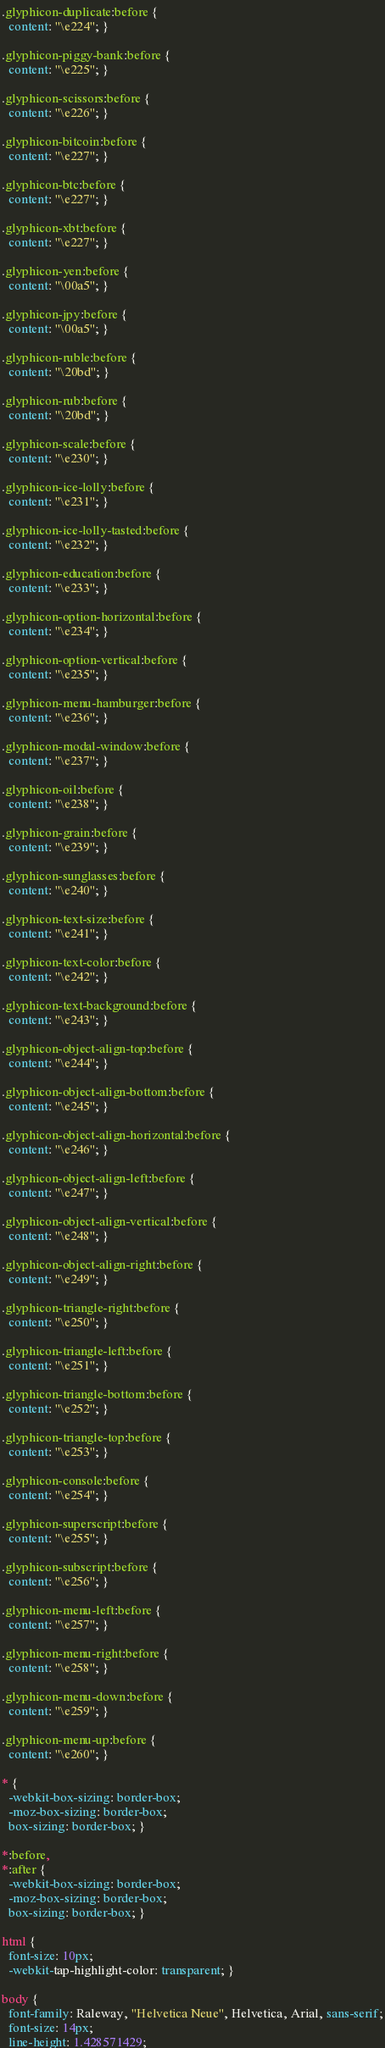Convert code to text. <code><loc_0><loc_0><loc_500><loc_500><_CSS_>
.glyphicon-duplicate:before {
  content: "\e224"; }

.glyphicon-piggy-bank:before {
  content: "\e225"; }

.glyphicon-scissors:before {
  content: "\e226"; }

.glyphicon-bitcoin:before {
  content: "\e227"; }

.glyphicon-btc:before {
  content: "\e227"; }

.glyphicon-xbt:before {
  content: "\e227"; }

.glyphicon-yen:before {
  content: "\00a5"; }

.glyphicon-jpy:before {
  content: "\00a5"; }

.glyphicon-ruble:before {
  content: "\20bd"; }

.glyphicon-rub:before {
  content: "\20bd"; }

.glyphicon-scale:before {
  content: "\e230"; }

.glyphicon-ice-lolly:before {
  content: "\e231"; }

.glyphicon-ice-lolly-tasted:before {
  content: "\e232"; }

.glyphicon-education:before {
  content: "\e233"; }

.glyphicon-option-horizontal:before {
  content: "\e234"; }

.glyphicon-option-vertical:before {
  content: "\e235"; }

.glyphicon-menu-hamburger:before {
  content: "\e236"; }

.glyphicon-modal-window:before {
  content: "\e237"; }

.glyphicon-oil:before {
  content: "\e238"; }

.glyphicon-grain:before {
  content: "\e239"; }

.glyphicon-sunglasses:before {
  content: "\e240"; }

.glyphicon-text-size:before {
  content: "\e241"; }

.glyphicon-text-color:before {
  content: "\e242"; }

.glyphicon-text-background:before {
  content: "\e243"; }

.glyphicon-object-align-top:before {
  content: "\e244"; }

.glyphicon-object-align-bottom:before {
  content: "\e245"; }

.glyphicon-object-align-horizontal:before {
  content: "\e246"; }

.glyphicon-object-align-left:before {
  content: "\e247"; }

.glyphicon-object-align-vertical:before {
  content: "\e248"; }

.glyphicon-object-align-right:before {
  content: "\e249"; }

.glyphicon-triangle-right:before {
  content: "\e250"; }

.glyphicon-triangle-left:before {
  content: "\e251"; }

.glyphicon-triangle-bottom:before {
  content: "\e252"; }

.glyphicon-triangle-top:before {
  content: "\e253"; }

.glyphicon-console:before {
  content: "\e254"; }

.glyphicon-superscript:before {
  content: "\e255"; }

.glyphicon-subscript:before {
  content: "\e256"; }

.glyphicon-menu-left:before {
  content: "\e257"; }

.glyphicon-menu-right:before {
  content: "\e258"; }

.glyphicon-menu-down:before {
  content: "\e259"; }

.glyphicon-menu-up:before {
  content: "\e260"; }

* {
  -webkit-box-sizing: border-box;
  -moz-box-sizing: border-box;
  box-sizing: border-box; }

*:before,
*:after {
  -webkit-box-sizing: border-box;
  -moz-box-sizing: border-box;
  box-sizing: border-box; }

html {
  font-size: 10px;
  -webkit-tap-highlight-color: transparent; }

body {
  font-family: Raleway, "Helvetica Neue", Helvetica, Arial, sans-serif;
  font-size: 14px;
  line-height: 1.428571429;</code> 